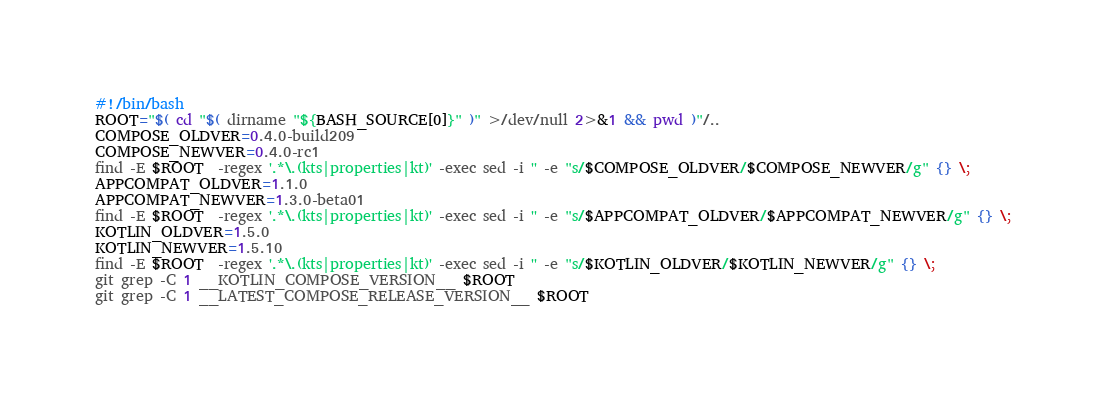<code> <loc_0><loc_0><loc_500><loc_500><_Bash_>#!/bin/bash
ROOT="$( cd "$( dirname "${BASH_SOURCE[0]}" )" >/dev/null 2>&1 && pwd )"/..
COMPOSE_OLDVER=0.4.0-build209
COMPOSE_NEWVER=0.4.0-rc1
find -E $ROOT  -regex '.*\.(kts|properties|kt)' -exec sed -i '' -e "s/$COMPOSE_OLDVER/$COMPOSE_NEWVER/g" {} \;
APPCOMPAT_OLDVER=1.1.0
APPCOMPAT_NEWVER=1.3.0-beta01
find -E $ROOT  -regex '.*\.(kts|properties|kt)' -exec sed -i '' -e "s/$APPCOMPAT_OLDVER/$APPCOMPAT_NEWVER/g" {} \;
KOTLIN_OLDVER=1.5.0
KOTLIN_NEWVER=1.5.10
find -E $ROOT  -regex '.*\.(kts|properties|kt)' -exec sed -i '' -e "s/$KOTLIN_OLDVER/$KOTLIN_NEWVER/g" {} \;
git grep -C 1 __KOTLIN_COMPOSE_VERSION__ $ROOT
git grep -C 1 __LATEST_COMPOSE_RELEASE_VERSION__ $ROOT
</code> 